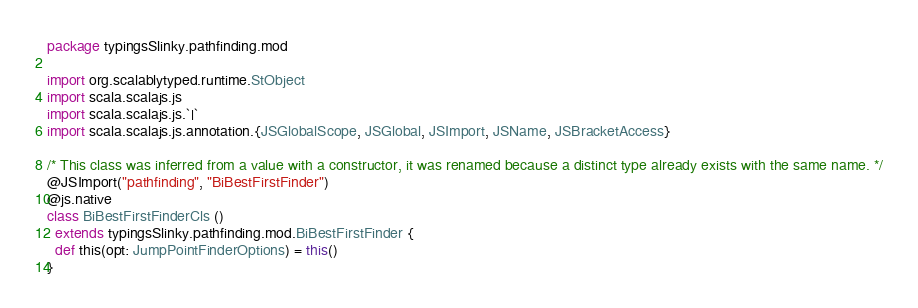Convert code to text. <code><loc_0><loc_0><loc_500><loc_500><_Scala_>package typingsSlinky.pathfinding.mod

import org.scalablytyped.runtime.StObject
import scala.scalajs.js
import scala.scalajs.js.`|`
import scala.scalajs.js.annotation.{JSGlobalScope, JSGlobal, JSImport, JSName, JSBracketAccess}

/* This class was inferred from a value with a constructor, it was renamed because a distinct type already exists with the same name. */
@JSImport("pathfinding", "BiBestFirstFinder")
@js.native
class BiBestFirstFinderCls ()
  extends typingsSlinky.pathfinding.mod.BiBestFirstFinder {
  def this(opt: JumpPointFinderOptions) = this()
}
</code> 